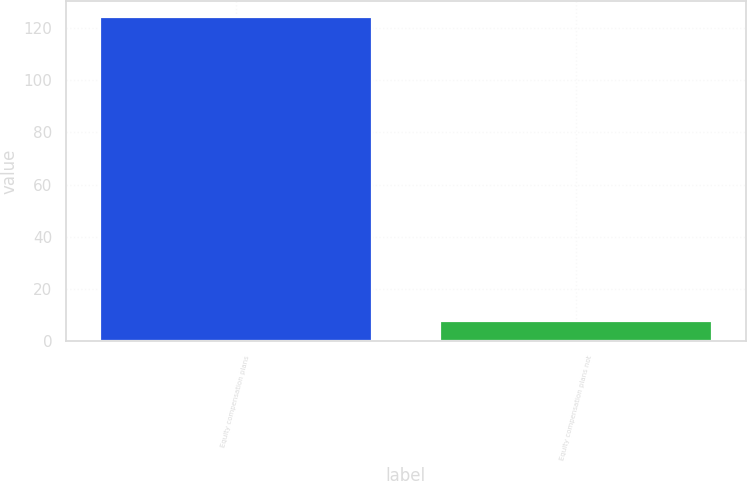Convert chart to OTSL. <chart><loc_0><loc_0><loc_500><loc_500><bar_chart><fcel>Equity compensation plans<fcel>Equity compensation plans not<nl><fcel>124<fcel>8<nl></chart> 